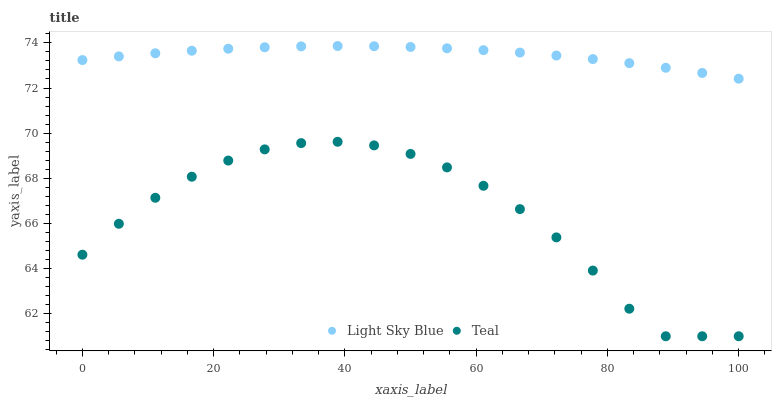Does Teal have the minimum area under the curve?
Answer yes or no. Yes. Does Light Sky Blue have the maximum area under the curve?
Answer yes or no. Yes. Does Teal have the maximum area under the curve?
Answer yes or no. No. Is Light Sky Blue the smoothest?
Answer yes or no. Yes. Is Teal the roughest?
Answer yes or no. Yes. Is Teal the smoothest?
Answer yes or no. No. Does Teal have the lowest value?
Answer yes or no. Yes. Does Light Sky Blue have the highest value?
Answer yes or no. Yes. Does Teal have the highest value?
Answer yes or no. No. Is Teal less than Light Sky Blue?
Answer yes or no. Yes. Is Light Sky Blue greater than Teal?
Answer yes or no. Yes. Does Teal intersect Light Sky Blue?
Answer yes or no. No. 